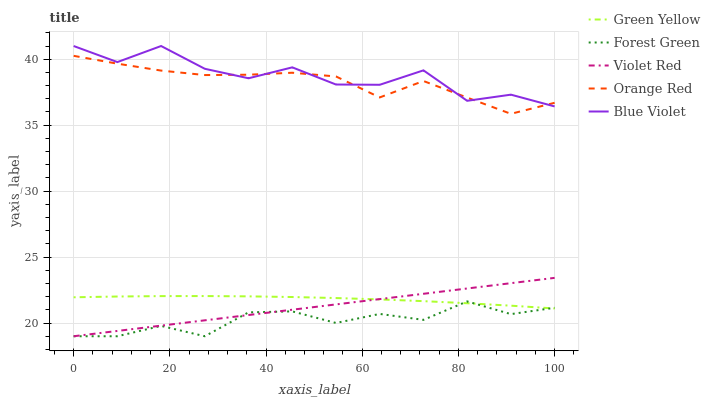Does Forest Green have the minimum area under the curve?
Answer yes or no. Yes. Does Blue Violet have the maximum area under the curve?
Answer yes or no. Yes. Does Green Yellow have the minimum area under the curve?
Answer yes or no. No. Does Green Yellow have the maximum area under the curve?
Answer yes or no. No. Is Violet Red the smoothest?
Answer yes or no. Yes. Is Blue Violet the roughest?
Answer yes or no. Yes. Is Green Yellow the smoothest?
Answer yes or no. No. Is Green Yellow the roughest?
Answer yes or no. No. Does Forest Green have the lowest value?
Answer yes or no. Yes. Does Green Yellow have the lowest value?
Answer yes or no. No. Does Blue Violet have the highest value?
Answer yes or no. Yes. Does Green Yellow have the highest value?
Answer yes or no. No. Is Green Yellow less than Orange Red?
Answer yes or no. Yes. Is Orange Red greater than Violet Red?
Answer yes or no. Yes. Does Blue Violet intersect Orange Red?
Answer yes or no. Yes. Is Blue Violet less than Orange Red?
Answer yes or no. No. Is Blue Violet greater than Orange Red?
Answer yes or no. No. Does Green Yellow intersect Orange Red?
Answer yes or no. No. 